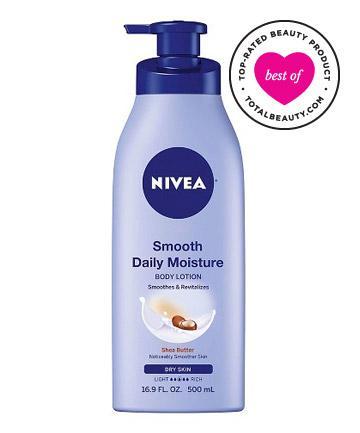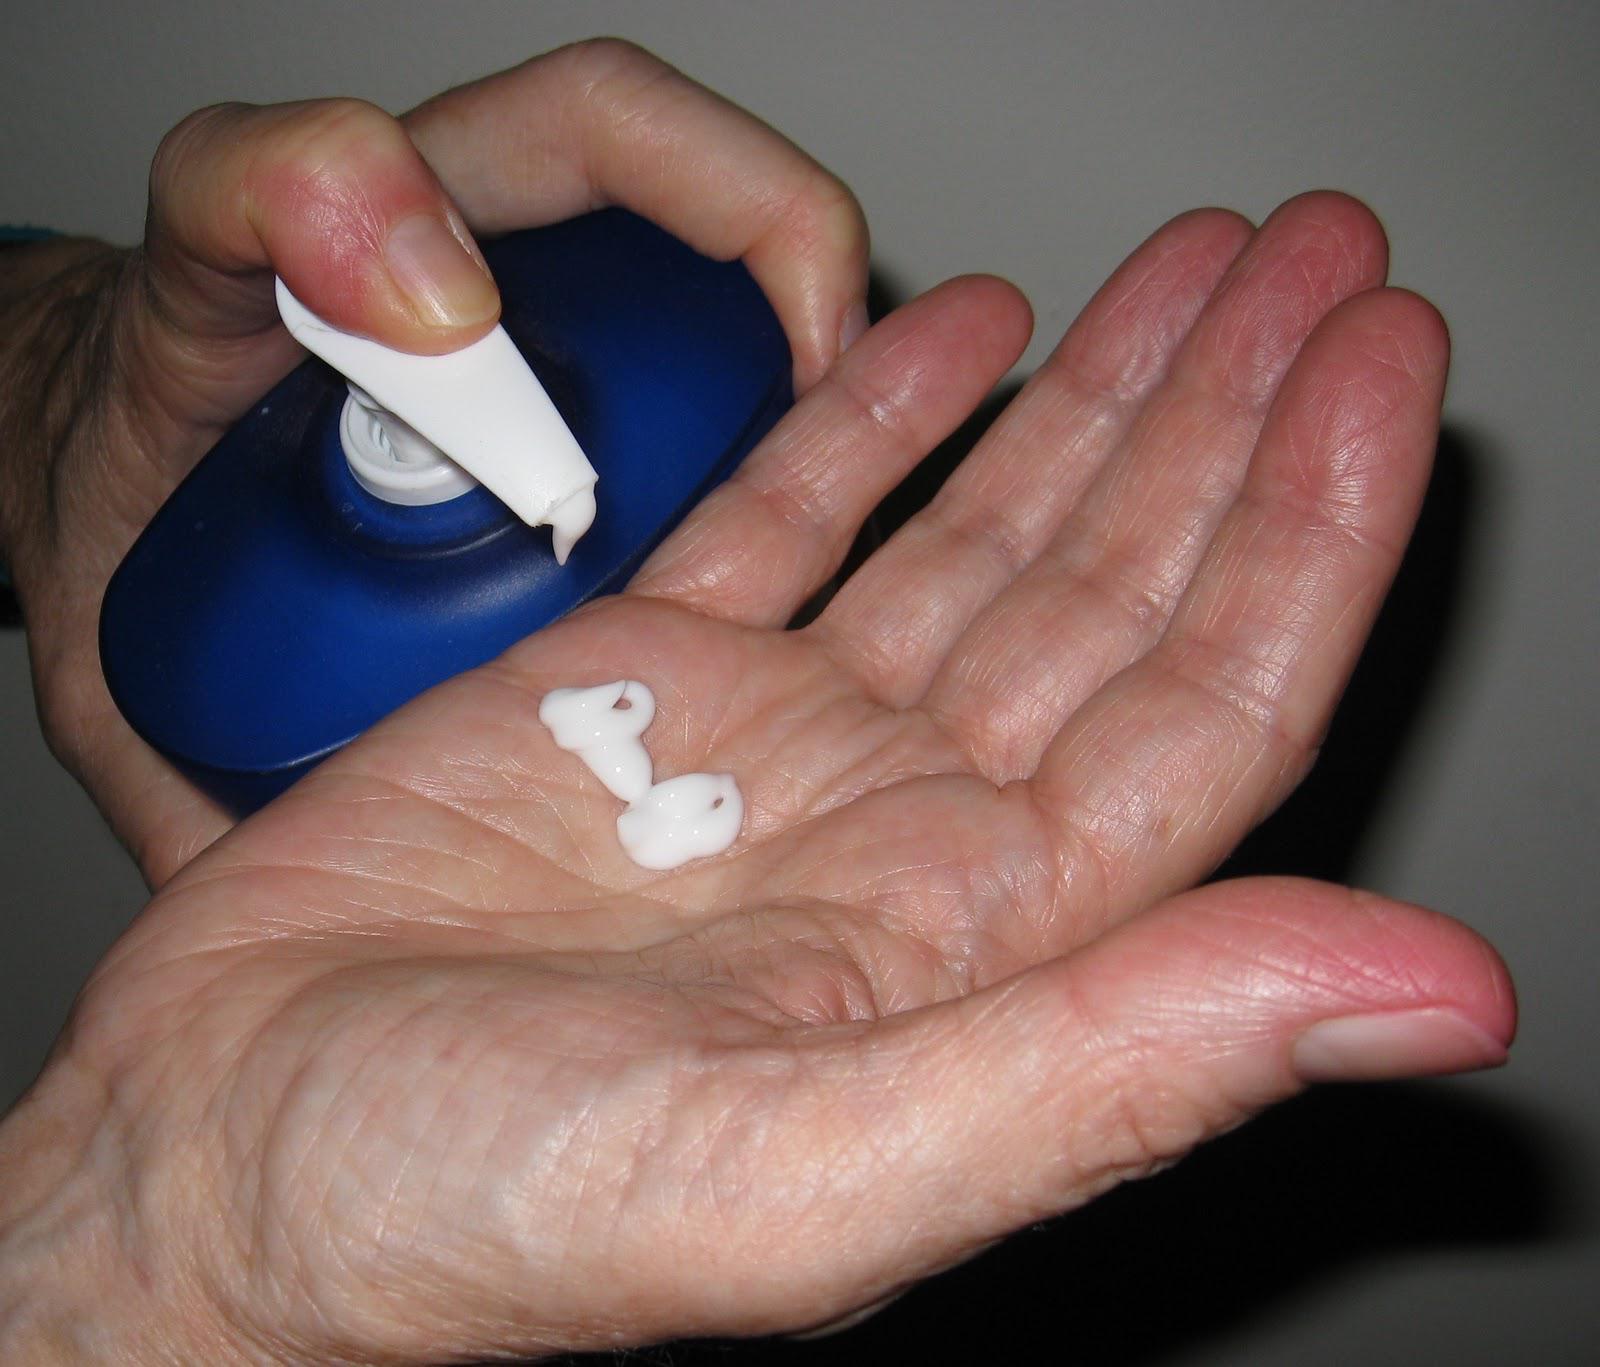The first image is the image on the left, the second image is the image on the right. Analyze the images presented: Is the assertion "the left image is a single lotion bottle with a pump top" valid? Answer yes or no. Yes. The first image is the image on the left, the second image is the image on the right. For the images shown, is this caption "The images don't show the lotion being applied to anyone's skin." true? Answer yes or no. No. 